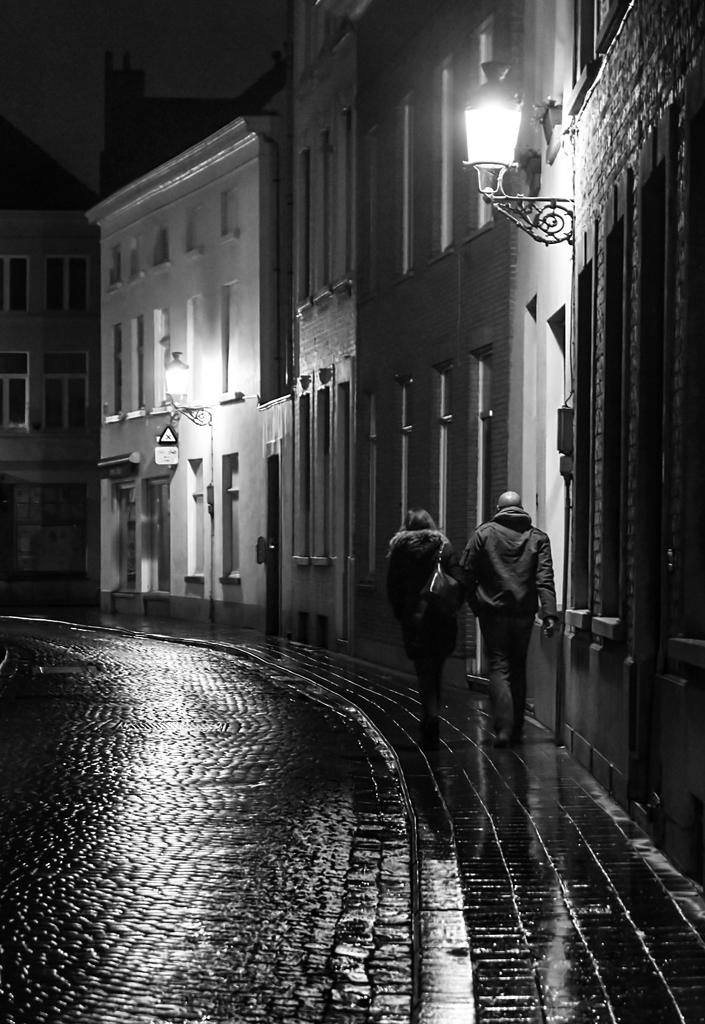What are the two persons in the image doing? The two persons are walking in the image. On what surface are the persons walking? The persons are walking on a pavement. What can be seen on the left side of the image? There is a road on the left side of the image. What is present on the right side of the image? There are buildings on the right side of the image. What feature do the buildings have? The buildings have lights. What is visible at the top of the image? The sky is visible at the top of the image. What grade did the committee give to the nail in the image? There is no committee, nail, or grading system present in the image. 